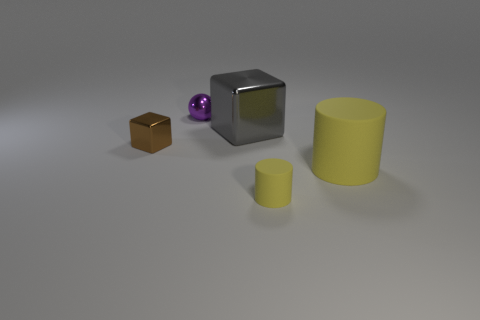Do the tiny purple thing and the large gray thing have the same material?
Provide a succinct answer. Yes. The brown shiny object that is the same shape as the gray thing is what size?
Keep it short and to the point. Small. What is the material of the thing that is behind the small yellow rubber cylinder and on the right side of the gray thing?
Provide a short and direct response. Rubber. Is the number of purple metal spheres on the right side of the purple sphere the same as the number of green cubes?
Offer a very short reply. Yes. How many things are either tiny metallic balls that are right of the tiny brown cube or metallic cubes?
Your response must be concise. 3. Does the tiny object that is to the right of the tiny metallic ball have the same color as the large matte cylinder?
Provide a succinct answer. Yes. What size is the yellow matte cylinder left of the large rubber thing?
Offer a terse response. Small. What is the shape of the large object in front of the object that is to the left of the tiny ball?
Your answer should be compact. Cylinder. There is another object that is the same shape as the small rubber thing; what color is it?
Keep it short and to the point. Yellow. Is the size of the brown shiny cube in front of the purple sphere the same as the large rubber object?
Give a very brief answer. No. 